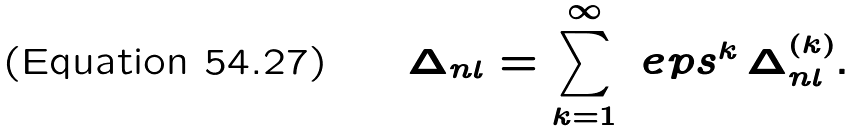Convert formula to latex. <formula><loc_0><loc_0><loc_500><loc_500>\Delta _ { n l } = \sum _ { k = 1 } ^ { \infty } \ e p s ^ { k } \, \Delta _ { n l } ^ { ( k ) } .</formula> 